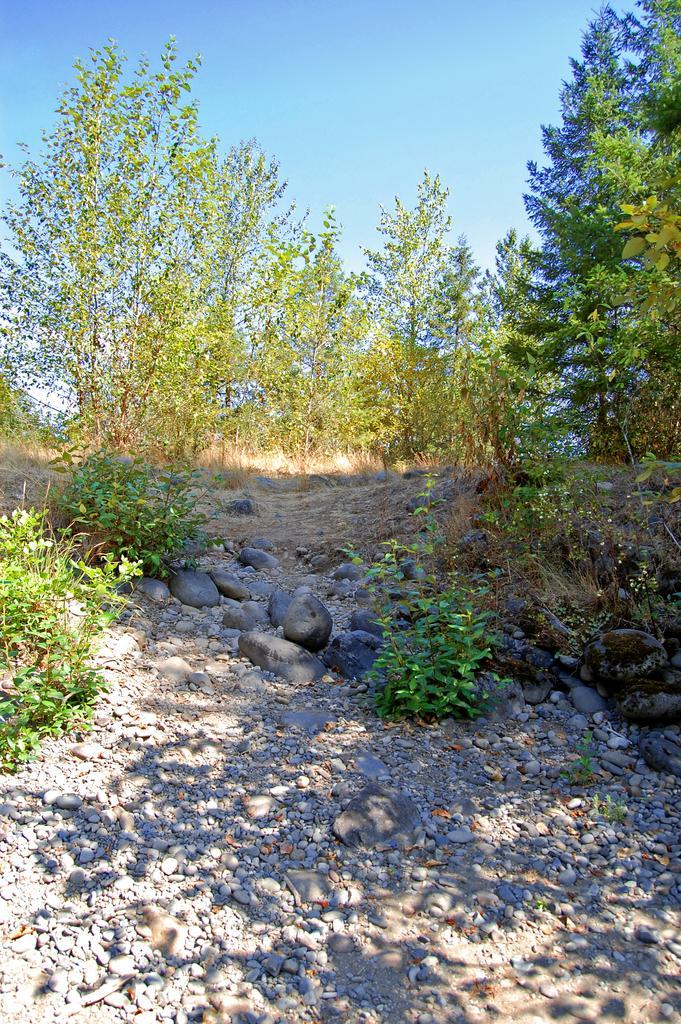Please provide a concise description of this image. In the image,there are many trees and plants and in between the trees there are some stones and sand. 